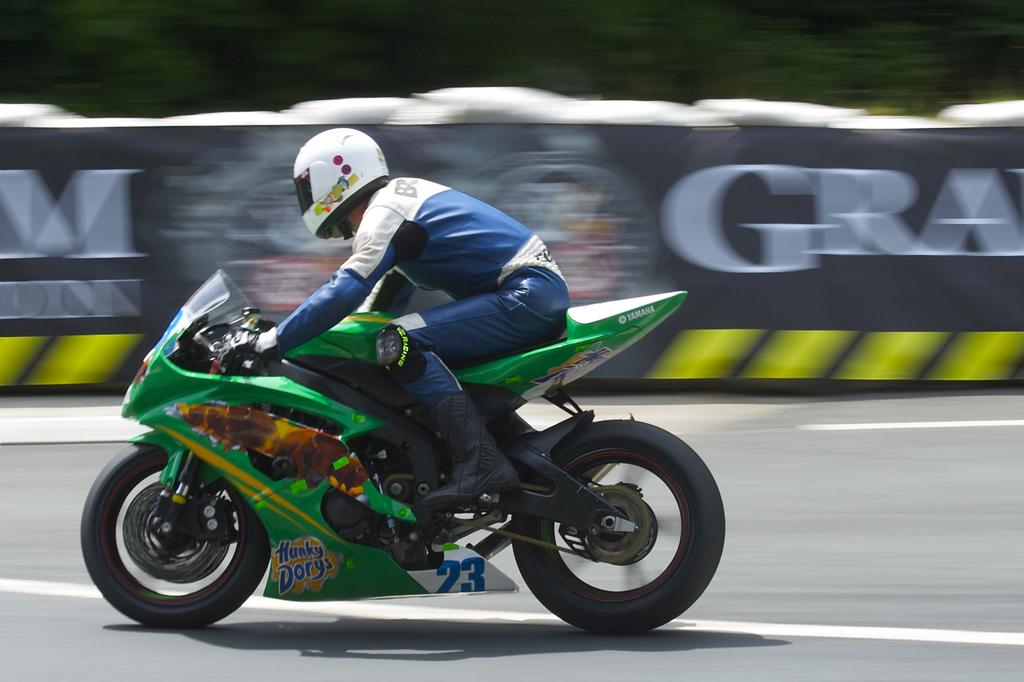What is the person in the image doing? The person is sitting on a motorbike in the image. What safety gear is the person wearing? The person is wearing a helmet. Can you describe the background of the image? The background of the image is blurry. What additional feature can be seen in the image? There is a banner visible in the image. What type of haircut does the person have in the image? There is no information about the person's haircut in the image. 